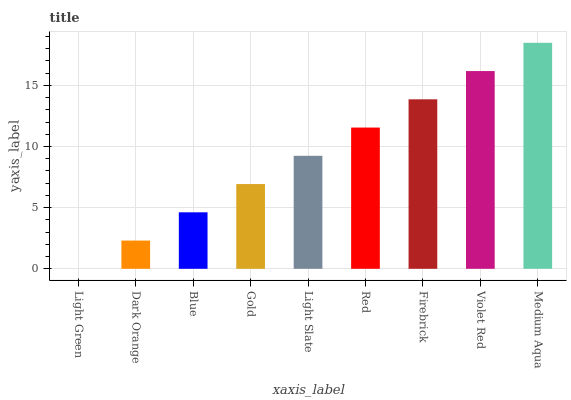Is Light Green the minimum?
Answer yes or no. Yes. Is Medium Aqua the maximum?
Answer yes or no. Yes. Is Dark Orange the minimum?
Answer yes or no. No. Is Dark Orange the maximum?
Answer yes or no. No. Is Dark Orange greater than Light Green?
Answer yes or no. Yes. Is Light Green less than Dark Orange?
Answer yes or no. Yes. Is Light Green greater than Dark Orange?
Answer yes or no. No. Is Dark Orange less than Light Green?
Answer yes or no. No. Is Light Slate the high median?
Answer yes or no. Yes. Is Light Slate the low median?
Answer yes or no. Yes. Is Violet Red the high median?
Answer yes or no. No. Is Light Green the low median?
Answer yes or no. No. 